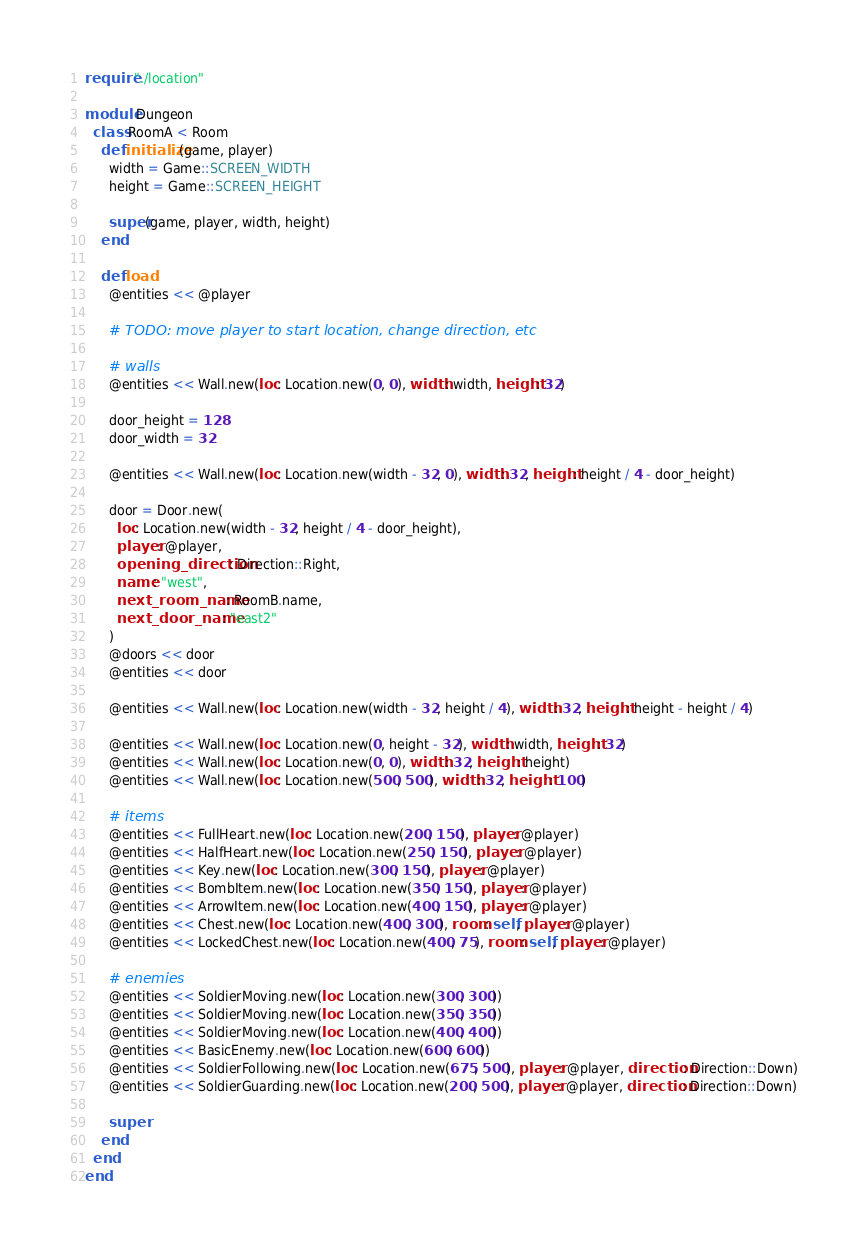<code> <loc_0><loc_0><loc_500><loc_500><_Crystal_>require "./location"

module Dungeon
  class RoomA < Room
    def initialize(game, player)
      width = Game::SCREEN_WIDTH
      height = Game::SCREEN_HEIGHT

      super(game, player, width, height)
    end

    def load
      @entities << @player

      # TODO: move player to start location, change direction, etc

      # walls
      @entities << Wall.new(loc: Location.new(0, 0), width: width, height: 32)

      door_height = 128
      door_width = 32

      @entities << Wall.new(loc: Location.new(width - 32, 0), width: 32, height: height / 4 - door_height)

      door = Door.new(
        loc: Location.new(width - 32, height / 4 - door_height),
        player: @player,
        opening_direction: Direction::Right,
        name: "west",
        next_room_name: RoomB.name,
        next_door_name: "east2"
      )
      @doors << door
      @entities << door

      @entities << Wall.new(loc: Location.new(width - 32, height / 4), width: 32, height: height - height / 4)

      @entities << Wall.new(loc: Location.new(0, height - 32), width: width, height: 32)
      @entities << Wall.new(loc: Location.new(0, 0), width: 32, height: height)
      @entities << Wall.new(loc: Location.new(500, 500), width: 32, height: 100)

      # items
      @entities << FullHeart.new(loc: Location.new(200, 150), player: @player)
      @entities << HalfHeart.new(loc: Location.new(250, 150), player: @player)
      @entities << Key.new(loc: Location.new(300, 150), player: @player)
      @entities << BombItem.new(loc: Location.new(350, 150), player: @player)
      @entities << ArrowItem.new(loc: Location.new(400, 150), player: @player)
      @entities << Chest.new(loc: Location.new(400, 300), room: self, player: @player)
      @entities << LockedChest.new(loc: Location.new(400, 75), room: self, player: @player)

      # enemies
      @entities << SoldierMoving.new(loc: Location.new(300, 300))
      @entities << SoldierMoving.new(loc: Location.new(350, 350))
      @entities << SoldierMoving.new(loc: Location.new(400, 400))
      @entities << BasicEnemy.new(loc: Location.new(600, 600))
      @entities << SoldierFollowing.new(loc: Location.new(675, 500), player: @player, direction: Direction::Down)
      @entities << SoldierGuarding.new(loc: Location.new(200, 500), player: @player, direction: Direction::Down)

      super
    end
  end
end
</code> 